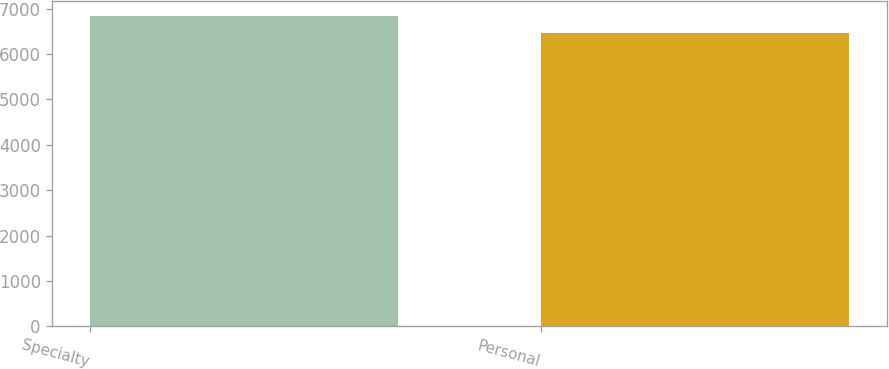<chart> <loc_0><loc_0><loc_500><loc_500><bar_chart><fcel>Specialty<fcel>Personal<nl><fcel>6836<fcel>6474<nl></chart> 